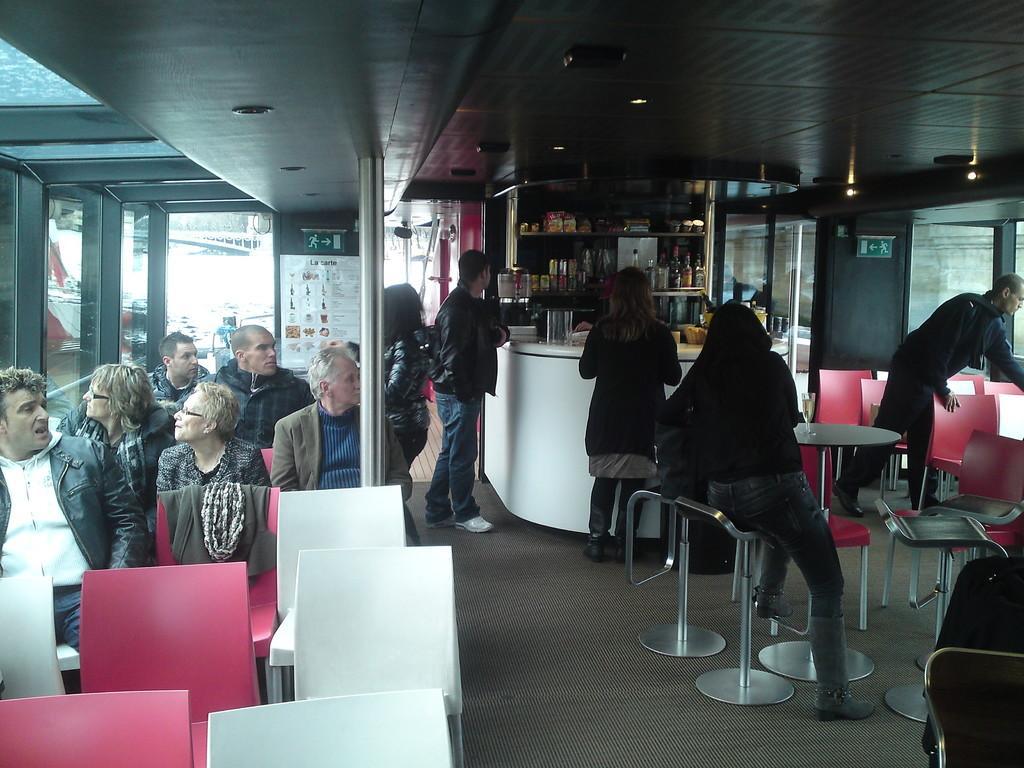Please provide a concise description of this image. There are few people sitting on the chair on the left and few people are standing at the counter table. In the background we can see bottles in a rack,pole and a entry door. On the rooftop there are lights. 